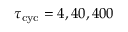Convert formula to latex. <formula><loc_0><loc_0><loc_500><loc_500>\tau _ { c y c } = 4 , 4 0 , 4 0 0</formula> 